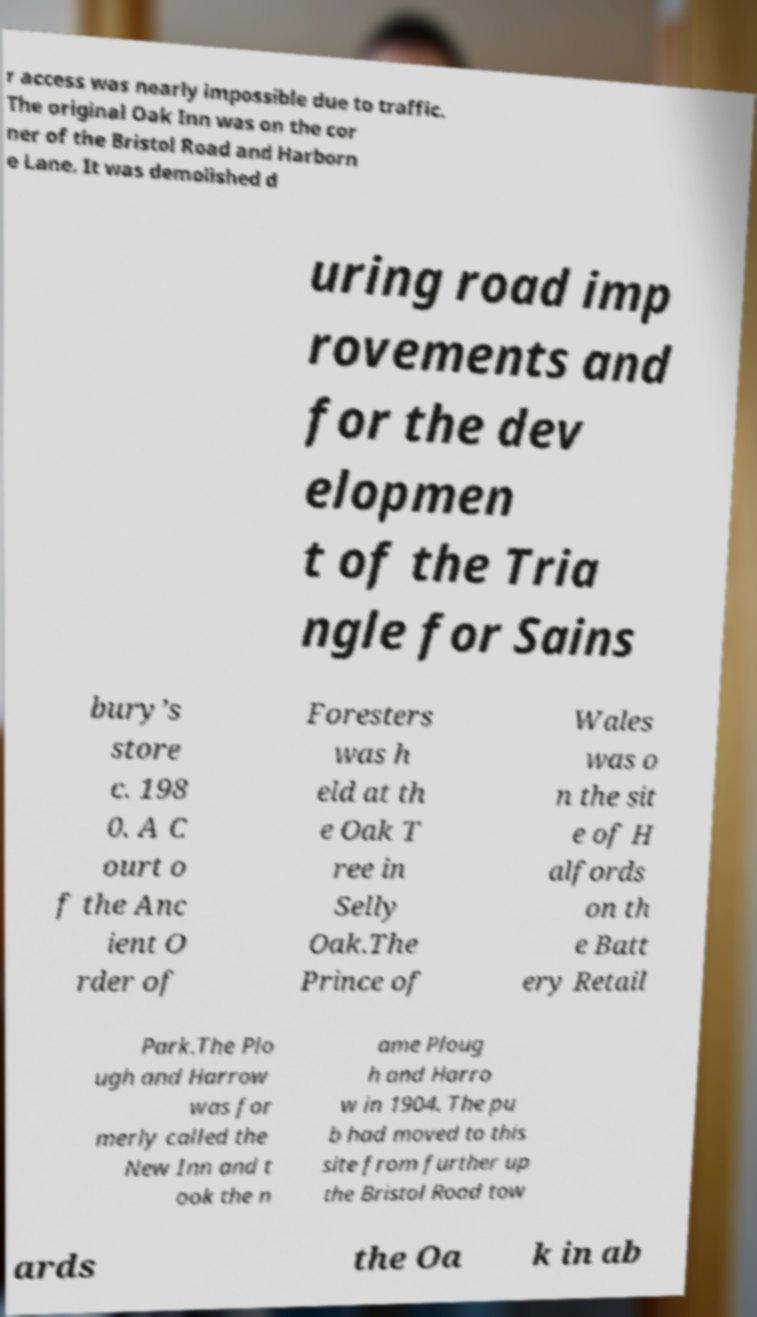Can you accurately transcribe the text from the provided image for me? r access was nearly impossible due to traffic. The original Oak Inn was on the cor ner of the Bristol Road and Harborn e Lane. It was demolished d uring road imp rovements and for the dev elopmen t of the Tria ngle for Sains bury’s store c. 198 0. A C ourt o f the Anc ient O rder of Foresters was h eld at th e Oak T ree in Selly Oak.The Prince of Wales was o n the sit e of H alfords on th e Batt ery Retail Park.The Plo ugh and Harrow was for merly called the New Inn and t ook the n ame Ploug h and Harro w in 1904. The pu b had moved to this site from further up the Bristol Road tow ards the Oa k in ab 